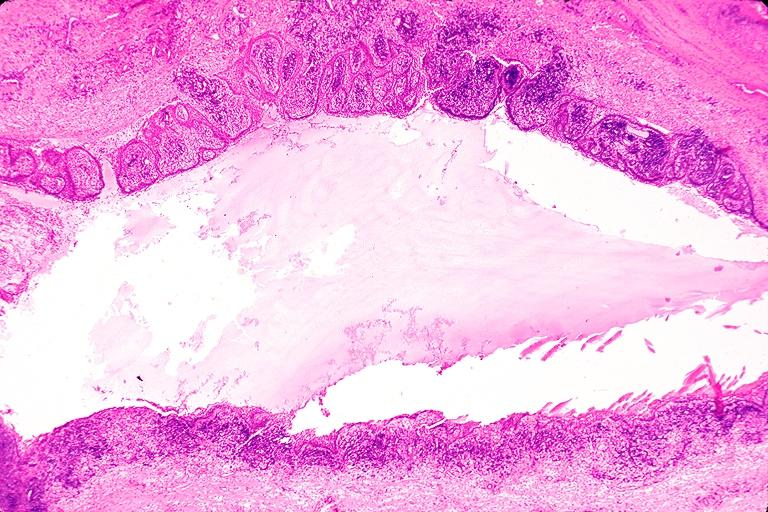does aldehyde fuscin show radicular cyst?
Answer the question using a single word or phrase. No 